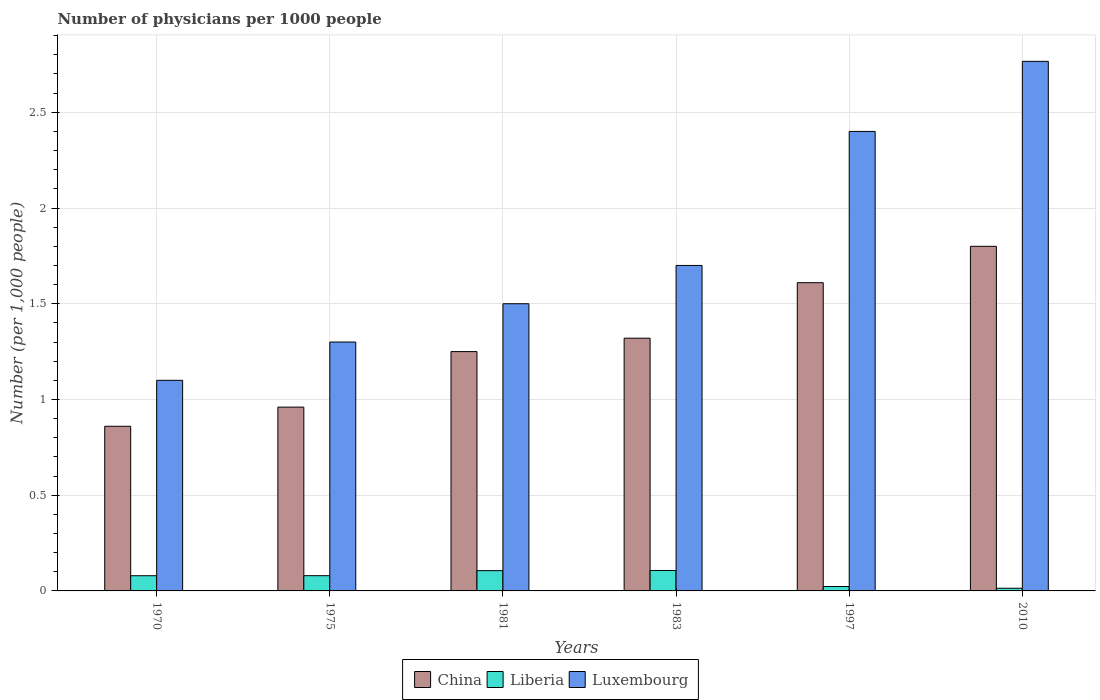How many bars are there on the 1st tick from the left?
Your answer should be compact. 3. In how many cases, is the number of bars for a given year not equal to the number of legend labels?
Your response must be concise. 0. What is the number of physicians in China in 1970?
Provide a succinct answer. 0.86. Across all years, what is the maximum number of physicians in Liberia?
Provide a succinct answer. 0.11. Across all years, what is the minimum number of physicians in Luxembourg?
Ensure brevity in your answer.  1.1. In which year was the number of physicians in China maximum?
Provide a succinct answer. 2010. In which year was the number of physicians in Liberia minimum?
Make the answer very short. 2010. What is the total number of physicians in Liberia in the graph?
Provide a succinct answer. 0.41. What is the difference between the number of physicians in China in 1970 and that in 2010?
Offer a very short reply. -0.94. What is the difference between the number of physicians in China in 1975 and the number of physicians in Luxembourg in 1997?
Your answer should be very brief. -1.44. What is the average number of physicians in Luxembourg per year?
Your answer should be compact. 1.79. In the year 1997, what is the difference between the number of physicians in China and number of physicians in Liberia?
Provide a succinct answer. 1.59. In how many years, is the number of physicians in China greater than 0.2?
Make the answer very short. 6. What is the ratio of the number of physicians in Liberia in 1975 to that in 1997?
Your answer should be compact. 3.46. Is the number of physicians in China in 1983 less than that in 2010?
Your response must be concise. Yes. What is the difference between the highest and the second highest number of physicians in China?
Give a very brief answer. 0.19. What is the difference between the highest and the lowest number of physicians in Liberia?
Make the answer very short. 0.09. What does the 2nd bar from the left in 1975 represents?
Your answer should be very brief. Liberia. How many bars are there?
Offer a terse response. 18. Are the values on the major ticks of Y-axis written in scientific E-notation?
Provide a succinct answer. No. Does the graph contain grids?
Your answer should be compact. Yes. How many legend labels are there?
Give a very brief answer. 3. What is the title of the graph?
Offer a terse response. Number of physicians per 1000 people. What is the label or title of the Y-axis?
Your response must be concise. Number (per 1,0 people). What is the Number (per 1,000 people) of China in 1970?
Your answer should be compact. 0.86. What is the Number (per 1,000 people) in Liberia in 1970?
Ensure brevity in your answer.  0.08. What is the Number (per 1,000 people) in China in 1975?
Offer a terse response. 0.96. What is the Number (per 1,000 people) of Liberia in 1975?
Provide a short and direct response. 0.08. What is the Number (per 1,000 people) of Luxembourg in 1975?
Offer a terse response. 1.3. What is the Number (per 1,000 people) in Liberia in 1981?
Offer a very short reply. 0.11. What is the Number (per 1,000 people) of Luxembourg in 1981?
Keep it short and to the point. 1.5. What is the Number (per 1,000 people) of China in 1983?
Provide a succinct answer. 1.32. What is the Number (per 1,000 people) of Liberia in 1983?
Ensure brevity in your answer.  0.11. What is the Number (per 1,000 people) of China in 1997?
Your answer should be compact. 1.61. What is the Number (per 1,000 people) of Liberia in 1997?
Ensure brevity in your answer.  0.02. What is the Number (per 1,000 people) of Luxembourg in 1997?
Ensure brevity in your answer.  2.4. What is the Number (per 1,000 people) in Liberia in 2010?
Your response must be concise. 0.01. What is the Number (per 1,000 people) in Luxembourg in 2010?
Make the answer very short. 2.77. Across all years, what is the maximum Number (per 1,000 people) in Liberia?
Keep it short and to the point. 0.11. Across all years, what is the maximum Number (per 1,000 people) of Luxembourg?
Ensure brevity in your answer.  2.77. Across all years, what is the minimum Number (per 1,000 people) of China?
Offer a terse response. 0.86. Across all years, what is the minimum Number (per 1,000 people) of Liberia?
Your response must be concise. 0.01. Across all years, what is the minimum Number (per 1,000 people) in Luxembourg?
Provide a short and direct response. 1.1. What is the total Number (per 1,000 people) of China in the graph?
Your response must be concise. 7.8. What is the total Number (per 1,000 people) of Liberia in the graph?
Make the answer very short. 0.41. What is the total Number (per 1,000 people) in Luxembourg in the graph?
Make the answer very short. 10.77. What is the difference between the Number (per 1,000 people) in China in 1970 and that in 1975?
Ensure brevity in your answer.  -0.1. What is the difference between the Number (per 1,000 people) of Liberia in 1970 and that in 1975?
Make the answer very short. -0. What is the difference between the Number (per 1,000 people) of China in 1970 and that in 1981?
Ensure brevity in your answer.  -0.39. What is the difference between the Number (per 1,000 people) in Liberia in 1970 and that in 1981?
Your answer should be very brief. -0.03. What is the difference between the Number (per 1,000 people) in Luxembourg in 1970 and that in 1981?
Provide a succinct answer. -0.4. What is the difference between the Number (per 1,000 people) in China in 1970 and that in 1983?
Ensure brevity in your answer.  -0.46. What is the difference between the Number (per 1,000 people) of Liberia in 1970 and that in 1983?
Keep it short and to the point. -0.03. What is the difference between the Number (per 1,000 people) of Luxembourg in 1970 and that in 1983?
Your response must be concise. -0.6. What is the difference between the Number (per 1,000 people) of China in 1970 and that in 1997?
Offer a terse response. -0.75. What is the difference between the Number (per 1,000 people) of Liberia in 1970 and that in 1997?
Offer a very short reply. 0.06. What is the difference between the Number (per 1,000 people) in Luxembourg in 1970 and that in 1997?
Your answer should be very brief. -1.3. What is the difference between the Number (per 1,000 people) in China in 1970 and that in 2010?
Make the answer very short. -0.94. What is the difference between the Number (per 1,000 people) in Liberia in 1970 and that in 2010?
Provide a short and direct response. 0.07. What is the difference between the Number (per 1,000 people) in Luxembourg in 1970 and that in 2010?
Your response must be concise. -1.67. What is the difference between the Number (per 1,000 people) in China in 1975 and that in 1981?
Keep it short and to the point. -0.29. What is the difference between the Number (per 1,000 people) of Liberia in 1975 and that in 1981?
Your answer should be compact. -0.03. What is the difference between the Number (per 1,000 people) of Luxembourg in 1975 and that in 1981?
Provide a short and direct response. -0.2. What is the difference between the Number (per 1,000 people) in China in 1975 and that in 1983?
Keep it short and to the point. -0.36. What is the difference between the Number (per 1,000 people) of Liberia in 1975 and that in 1983?
Provide a succinct answer. -0.03. What is the difference between the Number (per 1,000 people) in Luxembourg in 1975 and that in 1983?
Your response must be concise. -0.4. What is the difference between the Number (per 1,000 people) in China in 1975 and that in 1997?
Ensure brevity in your answer.  -0.65. What is the difference between the Number (per 1,000 people) in Liberia in 1975 and that in 1997?
Provide a succinct answer. 0.06. What is the difference between the Number (per 1,000 people) in China in 1975 and that in 2010?
Offer a very short reply. -0.84. What is the difference between the Number (per 1,000 people) in Liberia in 1975 and that in 2010?
Provide a succinct answer. 0.07. What is the difference between the Number (per 1,000 people) in Luxembourg in 1975 and that in 2010?
Ensure brevity in your answer.  -1.47. What is the difference between the Number (per 1,000 people) in China in 1981 and that in 1983?
Offer a terse response. -0.07. What is the difference between the Number (per 1,000 people) of Liberia in 1981 and that in 1983?
Keep it short and to the point. -0. What is the difference between the Number (per 1,000 people) of Luxembourg in 1981 and that in 1983?
Offer a terse response. -0.2. What is the difference between the Number (per 1,000 people) in China in 1981 and that in 1997?
Provide a succinct answer. -0.36. What is the difference between the Number (per 1,000 people) in Liberia in 1981 and that in 1997?
Your response must be concise. 0.08. What is the difference between the Number (per 1,000 people) in China in 1981 and that in 2010?
Make the answer very short. -0.55. What is the difference between the Number (per 1,000 people) of Liberia in 1981 and that in 2010?
Your answer should be compact. 0.09. What is the difference between the Number (per 1,000 people) in Luxembourg in 1981 and that in 2010?
Your answer should be very brief. -1.27. What is the difference between the Number (per 1,000 people) in China in 1983 and that in 1997?
Your answer should be compact. -0.29. What is the difference between the Number (per 1,000 people) in Liberia in 1983 and that in 1997?
Your response must be concise. 0.08. What is the difference between the Number (per 1,000 people) of Luxembourg in 1983 and that in 1997?
Provide a short and direct response. -0.7. What is the difference between the Number (per 1,000 people) of China in 1983 and that in 2010?
Provide a succinct answer. -0.48. What is the difference between the Number (per 1,000 people) in Liberia in 1983 and that in 2010?
Provide a short and direct response. 0.09. What is the difference between the Number (per 1,000 people) of Luxembourg in 1983 and that in 2010?
Provide a succinct answer. -1.07. What is the difference between the Number (per 1,000 people) in China in 1997 and that in 2010?
Offer a very short reply. -0.19. What is the difference between the Number (per 1,000 people) of Liberia in 1997 and that in 2010?
Provide a succinct answer. 0.01. What is the difference between the Number (per 1,000 people) in Luxembourg in 1997 and that in 2010?
Provide a short and direct response. -0.37. What is the difference between the Number (per 1,000 people) of China in 1970 and the Number (per 1,000 people) of Liberia in 1975?
Your answer should be compact. 0.78. What is the difference between the Number (per 1,000 people) of China in 1970 and the Number (per 1,000 people) of Luxembourg in 1975?
Make the answer very short. -0.44. What is the difference between the Number (per 1,000 people) in Liberia in 1970 and the Number (per 1,000 people) in Luxembourg in 1975?
Provide a succinct answer. -1.22. What is the difference between the Number (per 1,000 people) of China in 1970 and the Number (per 1,000 people) of Liberia in 1981?
Offer a very short reply. 0.75. What is the difference between the Number (per 1,000 people) of China in 1970 and the Number (per 1,000 people) of Luxembourg in 1981?
Your answer should be compact. -0.64. What is the difference between the Number (per 1,000 people) of Liberia in 1970 and the Number (per 1,000 people) of Luxembourg in 1981?
Your response must be concise. -1.42. What is the difference between the Number (per 1,000 people) in China in 1970 and the Number (per 1,000 people) in Liberia in 1983?
Give a very brief answer. 0.75. What is the difference between the Number (per 1,000 people) of China in 1970 and the Number (per 1,000 people) of Luxembourg in 1983?
Offer a terse response. -0.84. What is the difference between the Number (per 1,000 people) of Liberia in 1970 and the Number (per 1,000 people) of Luxembourg in 1983?
Provide a succinct answer. -1.62. What is the difference between the Number (per 1,000 people) of China in 1970 and the Number (per 1,000 people) of Liberia in 1997?
Your response must be concise. 0.84. What is the difference between the Number (per 1,000 people) in China in 1970 and the Number (per 1,000 people) in Luxembourg in 1997?
Provide a short and direct response. -1.54. What is the difference between the Number (per 1,000 people) of Liberia in 1970 and the Number (per 1,000 people) of Luxembourg in 1997?
Provide a succinct answer. -2.32. What is the difference between the Number (per 1,000 people) of China in 1970 and the Number (per 1,000 people) of Liberia in 2010?
Ensure brevity in your answer.  0.85. What is the difference between the Number (per 1,000 people) of China in 1970 and the Number (per 1,000 people) of Luxembourg in 2010?
Make the answer very short. -1.91. What is the difference between the Number (per 1,000 people) of Liberia in 1970 and the Number (per 1,000 people) of Luxembourg in 2010?
Your answer should be compact. -2.69. What is the difference between the Number (per 1,000 people) of China in 1975 and the Number (per 1,000 people) of Liberia in 1981?
Make the answer very short. 0.85. What is the difference between the Number (per 1,000 people) in China in 1975 and the Number (per 1,000 people) in Luxembourg in 1981?
Give a very brief answer. -0.54. What is the difference between the Number (per 1,000 people) in Liberia in 1975 and the Number (per 1,000 people) in Luxembourg in 1981?
Provide a short and direct response. -1.42. What is the difference between the Number (per 1,000 people) in China in 1975 and the Number (per 1,000 people) in Liberia in 1983?
Keep it short and to the point. 0.85. What is the difference between the Number (per 1,000 people) in China in 1975 and the Number (per 1,000 people) in Luxembourg in 1983?
Ensure brevity in your answer.  -0.74. What is the difference between the Number (per 1,000 people) of Liberia in 1975 and the Number (per 1,000 people) of Luxembourg in 1983?
Provide a short and direct response. -1.62. What is the difference between the Number (per 1,000 people) in China in 1975 and the Number (per 1,000 people) in Liberia in 1997?
Keep it short and to the point. 0.94. What is the difference between the Number (per 1,000 people) in China in 1975 and the Number (per 1,000 people) in Luxembourg in 1997?
Your answer should be very brief. -1.44. What is the difference between the Number (per 1,000 people) of Liberia in 1975 and the Number (per 1,000 people) of Luxembourg in 1997?
Make the answer very short. -2.32. What is the difference between the Number (per 1,000 people) in China in 1975 and the Number (per 1,000 people) in Liberia in 2010?
Give a very brief answer. 0.95. What is the difference between the Number (per 1,000 people) of China in 1975 and the Number (per 1,000 people) of Luxembourg in 2010?
Keep it short and to the point. -1.81. What is the difference between the Number (per 1,000 people) of Liberia in 1975 and the Number (per 1,000 people) of Luxembourg in 2010?
Make the answer very short. -2.69. What is the difference between the Number (per 1,000 people) in China in 1981 and the Number (per 1,000 people) in Liberia in 1983?
Your answer should be compact. 1.14. What is the difference between the Number (per 1,000 people) of China in 1981 and the Number (per 1,000 people) of Luxembourg in 1983?
Offer a terse response. -0.45. What is the difference between the Number (per 1,000 people) in Liberia in 1981 and the Number (per 1,000 people) in Luxembourg in 1983?
Offer a terse response. -1.59. What is the difference between the Number (per 1,000 people) of China in 1981 and the Number (per 1,000 people) of Liberia in 1997?
Make the answer very short. 1.23. What is the difference between the Number (per 1,000 people) in China in 1981 and the Number (per 1,000 people) in Luxembourg in 1997?
Your answer should be compact. -1.15. What is the difference between the Number (per 1,000 people) in Liberia in 1981 and the Number (per 1,000 people) in Luxembourg in 1997?
Make the answer very short. -2.29. What is the difference between the Number (per 1,000 people) in China in 1981 and the Number (per 1,000 people) in Liberia in 2010?
Provide a short and direct response. 1.24. What is the difference between the Number (per 1,000 people) of China in 1981 and the Number (per 1,000 people) of Luxembourg in 2010?
Provide a short and direct response. -1.52. What is the difference between the Number (per 1,000 people) of Liberia in 1981 and the Number (per 1,000 people) of Luxembourg in 2010?
Keep it short and to the point. -2.66. What is the difference between the Number (per 1,000 people) in China in 1983 and the Number (per 1,000 people) in Liberia in 1997?
Offer a terse response. 1.3. What is the difference between the Number (per 1,000 people) in China in 1983 and the Number (per 1,000 people) in Luxembourg in 1997?
Give a very brief answer. -1.08. What is the difference between the Number (per 1,000 people) of Liberia in 1983 and the Number (per 1,000 people) of Luxembourg in 1997?
Make the answer very short. -2.29. What is the difference between the Number (per 1,000 people) in China in 1983 and the Number (per 1,000 people) in Liberia in 2010?
Offer a very short reply. 1.31. What is the difference between the Number (per 1,000 people) of China in 1983 and the Number (per 1,000 people) of Luxembourg in 2010?
Make the answer very short. -1.45. What is the difference between the Number (per 1,000 people) in Liberia in 1983 and the Number (per 1,000 people) in Luxembourg in 2010?
Make the answer very short. -2.66. What is the difference between the Number (per 1,000 people) of China in 1997 and the Number (per 1,000 people) of Liberia in 2010?
Your answer should be compact. 1.6. What is the difference between the Number (per 1,000 people) of China in 1997 and the Number (per 1,000 people) of Luxembourg in 2010?
Offer a very short reply. -1.16. What is the difference between the Number (per 1,000 people) in Liberia in 1997 and the Number (per 1,000 people) in Luxembourg in 2010?
Offer a very short reply. -2.74. What is the average Number (per 1,000 people) of China per year?
Ensure brevity in your answer.  1.3. What is the average Number (per 1,000 people) in Liberia per year?
Make the answer very short. 0.07. What is the average Number (per 1,000 people) in Luxembourg per year?
Offer a very short reply. 1.79. In the year 1970, what is the difference between the Number (per 1,000 people) of China and Number (per 1,000 people) of Liberia?
Your response must be concise. 0.78. In the year 1970, what is the difference between the Number (per 1,000 people) in China and Number (per 1,000 people) in Luxembourg?
Keep it short and to the point. -0.24. In the year 1970, what is the difference between the Number (per 1,000 people) of Liberia and Number (per 1,000 people) of Luxembourg?
Your answer should be compact. -1.02. In the year 1975, what is the difference between the Number (per 1,000 people) in China and Number (per 1,000 people) in Liberia?
Offer a very short reply. 0.88. In the year 1975, what is the difference between the Number (per 1,000 people) in China and Number (per 1,000 people) in Luxembourg?
Provide a succinct answer. -0.34. In the year 1975, what is the difference between the Number (per 1,000 people) in Liberia and Number (per 1,000 people) in Luxembourg?
Offer a terse response. -1.22. In the year 1981, what is the difference between the Number (per 1,000 people) of China and Number (per 1,000 people) of Liberia?
Offer a terse response. 1.14. In the year 1981, what is the difference between the Number (per 1,000 people) in China and Number (per 1,000 people) in Luxembourg?
Ensure brevity in your answer.  -0.25. In the year 1981, what is the difference between the Number (per 1,000 people) in Liberia and Number (per 1,000 people) in Luxembourg?
Ensure brevity in your answer.  -1.39. In the year 1983, what is the difference between the Number (per 1,000 people) in China and Number (per 1,000 people) in Liberia?
Give a very brief answer. 1.21. In the year 1983, what is the difference between the Number (per 1,000 people) in China and Number (per 1,000 people) in Luxembourg?
Your answer should be compact. -0.38. In the year 1983, what is the difference between the Number (per 1,000 people) in Liberia and Number (per 1,000 people) in Luxembourg?
Make the answer very short. -1.59. In the year 1997, what is the difference between the Number (per 1,000 people) in China and Number (per 1,000 people) in Liberia?
Your answer should be compact. 1.59. In the year 1997, what is the difference between the Number (per 1,000 people) of China and Number (per 1,000 people) of Luxembourg?
Provide a succinct answer. -0.79. In the year 1997, what is the difference between the Number (per 1,000 people) of Liberia and Number (per 1,000 people) of Luxembourg?
Your answer should be compact. -2.38. In the year 2010, what is the difference between the Number (per 1,000 people) of China and Number (per 1,000 people) of Liberia?
Provide a succinct answer. 1.79. In the year 2010, what is the difference between the Number (per 1,000 people) of China and Number (per 1,000 people) of Luxembourg?
Provide a succinct answer. -0.97. In the year 2010, what is the difference between the Number (per 1,000 people) in Liberia and Number (per 1,000 people) in Luxembourg?
Keep it short and to the point. -2.75. What is the ratio of the Number (per 1,000 people) in China in 1970 to that in 1975?
Provide a succinct answer. 0.9. What is the ratio of the Number (per 1,000 people) in Luxembourg in 1970 to that in 1975?
Your answer should be compact. 0.85. What is the ratio of the Number (per 1,000 people) of China in 1970 to that in 1981?
Give a very brief answer. 0.69. What is the ratio of the Number (per 1,000 people) in Liberia in 1970 to that in 1981?
Make the answer very short. 0.75. What is the ratio of the Number (per 1,000 people) of Luxembourg in 1970 to that in 1981?
Give a very brief answer. 0.73. What is the ratio of the Number (per 1,000 people) in China in 1970 to that in 1983?
Offer a very short reply. 0.65. What is the ratio of the Number (per 1,000 people) in Liberia in 1970 to that in 1983?
Provide a succinct answer. 0.74. What is the ratio of the Number (per 1,000 people) in Luxembourg in 1970 to that in 1983?
Your answer should be compact. 0.65. What is the ratio of the Number (per 1,000 people) of China in 1970 to that in 1997?
Your answer should be compact. 0.53. What is the ratio of the Number (per 1,000 people) of Liberia in 1970 to that in 1997?
Ensure brevity in your answer.  3.45. What is the ratio of the Number (per 1,000 people) of Luxembourg in 1970 to that in 1997?
Your response must be concise. 0.46. What is the ratio of the Number (per 1,000 people) in China in 1970 to that in 2010?
Provide a succinct answer. 0.48. What is the ratio of the Number (per 1,000 people) in Liberia in 1970 to that in 2010?
Give a very brief answer. 5.67. What is the ratio of the Number (per 1,000 people) in Luxembourg in 1970 to that in 2010?
Your answer should be very brief. 0.4. What is the ratio of the Number (per 1,000 people) in China in 1975 to that in 1981?
Offer a terse response. 0.77. What is the ratio of the Number (per 1,000 people) in Liberia in 1975 to that in 1981?
Offer a very short reply. 0.75. What is the ratio of the Number (per 1,000 people) of Luxembourg in 1975 to that in 1981?
Your answer should be compact. 0.87. What is the ratio of the Number (per 1,000 people) of China in 1975 to that in 1983?
Offer a very short reply. 0.73. What is the ratio of the Number (per 1,000 people) in Liberia in 1975 to that in 1983?
Give a very brief answer. 0.75. What is the ratio of the Number (per 1,000 people) in Luxembourg in 1975 to that in 1983?
Keep it short and to the point. 0.76. What is the ratio of the Number (per 1,000 people) in China in 1975 to that in 1997?
Provide a short and direct response. 0.6. What is the ratio of the Number (per 1,000 people) of Liberia in 1975 to that in 1997?
Ensure brevity in your answer.  3.46. What is the ratio of the Number (per 1,000 people) of Luxembourg in 1975 to that in 1997?
Offer a very short reply. 0.54. What is the ratio of the Number (per 1,000 people) of China in 1975 to that in 2010?
Provide a succinct answer. 0.53. What is the ratio of the Number (per 1,000 people) in Liberia in 1975 to that in 2010?
Ensure brevity in your answer.  5.69. What is the ratio of the Number (per 1,000 people) in Luxembourg in 1975 to that in 2010?
Provide a short and direct response. 0.47. What is the ratio of the Number (per 1,000 people) of China in 1981 to that in 1983?
Offer a very short reply. 0.95. What is the ratio of the Number (per 1,000 people) in Liberia in 1981 to that in 1983?
Ensure brevity in your answer.  0.99. What is the ratio of the Number (per 1,000 people) in Luxembourg in 1981 to that in 1983?
Your answer should be compact. 0.88. What is the ratio of the Number (per 1,000 people) in China in 1981 to that in 1997?
Your response must be concise. 0.78. What is the ratio of the Number (per 1,000 people) of China in 1981 to that in 2010?
Your response must be concise. 0.69. What is the ratio of the Number (per 1,000 people) of Liberia in 1981 to that in 2010?
Offer a terse response. 7.56. What is the ratio of the Number (per 1,000 people) in Luxembourg in 1981 to that in 2010?
Offer a very short reply. 0.54. What is the ratio of the Number (per 1,000 people) of China in 1983 to that in 1997?
Your answer should be very brief. 0.82. What is the ratio of the Number (per 1,000 people) of Liberia in 1983 to that in 1997?
Provide a short and direct response. 4.64. What is the ratio of the Number (per 1,000 people) in Luxembourg in 1983 to that in 1997?
Provide a succinct answer. 0.71. What is the ratio of the Number (per 1,000 people) in China in 1983 to that in 2010?
Give a very brief answer. 0.73. What is the ratio of the Number (per 1,000 people) in Liberia in 1983 to that in 2010?
Your response must be concise. 7.62. What is the ratio of the Number (per 1,000 people) in Luxembourg in 1983 to that in 2010?
Keep it short and to the point. 0.61. What is the ratio of the Number (per 1,000 people) of China in 1997 to that in 2010?
Your answer should be very brief. 0.89. What is the ratio of the Number (per 1,000 people) of Liberia in 1997 to that in 2010?
Keep it short and to the point. 1.64. What is the ratio of the Number (per 1,000 people) of Luxembourg in 1997 to that in 2010?
Your answer should be compact. 0.87. What is the difference between the highest and the second highest Number (per 1,000 people) in China?
Offer a terse response. 0.19. What is the difference between the highest and the second highest Number (per 1,000 people) of Liberia?
Give a very brief answer. 0. What is the difference between the highest and the second highest Number (per 1,000 people) of Luxembourg?
Give a very brief answer. 0.37. What is the difference between the highest and the lowest Number (per 1,000 people) of Liberia?
Give a very brief answer. 0.09. What is the difference between the highest and the lowest Number (per 1,000 people) in Luxembourg?
Your response must be concise. 1.67. 